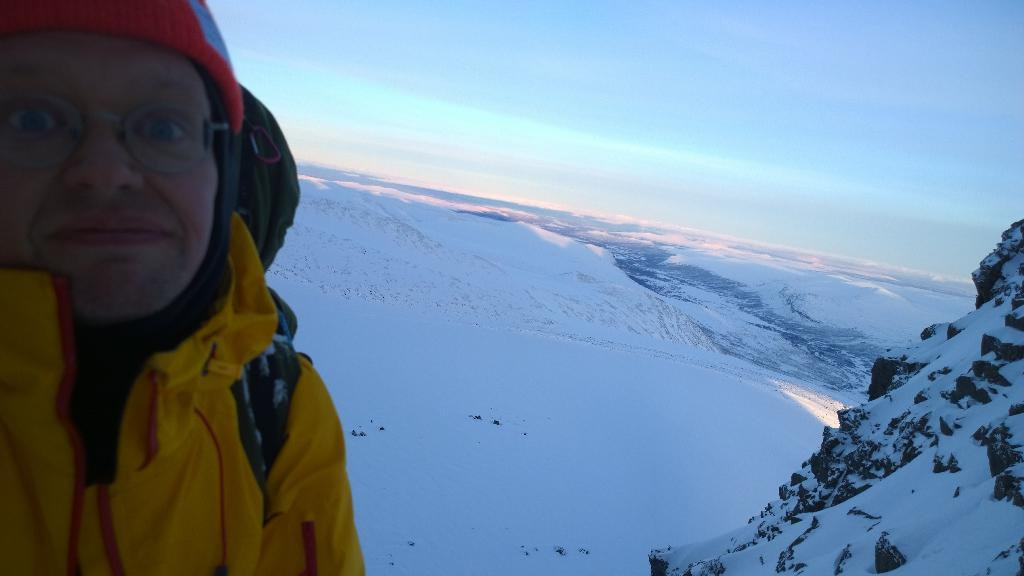Who or what is present in the image? There is a person in the image. What type of natural landscape can be seen in the image? There are snowy mountains in the image. What part of the environment is visible in the background of the image? The sky is visible in the background of the image. What type of crack is visible in the image? There is no crack present in the image. What time of day is depicted in the image? The time of day cannot be determined from the image alone, as there are no specific indicators of time. 